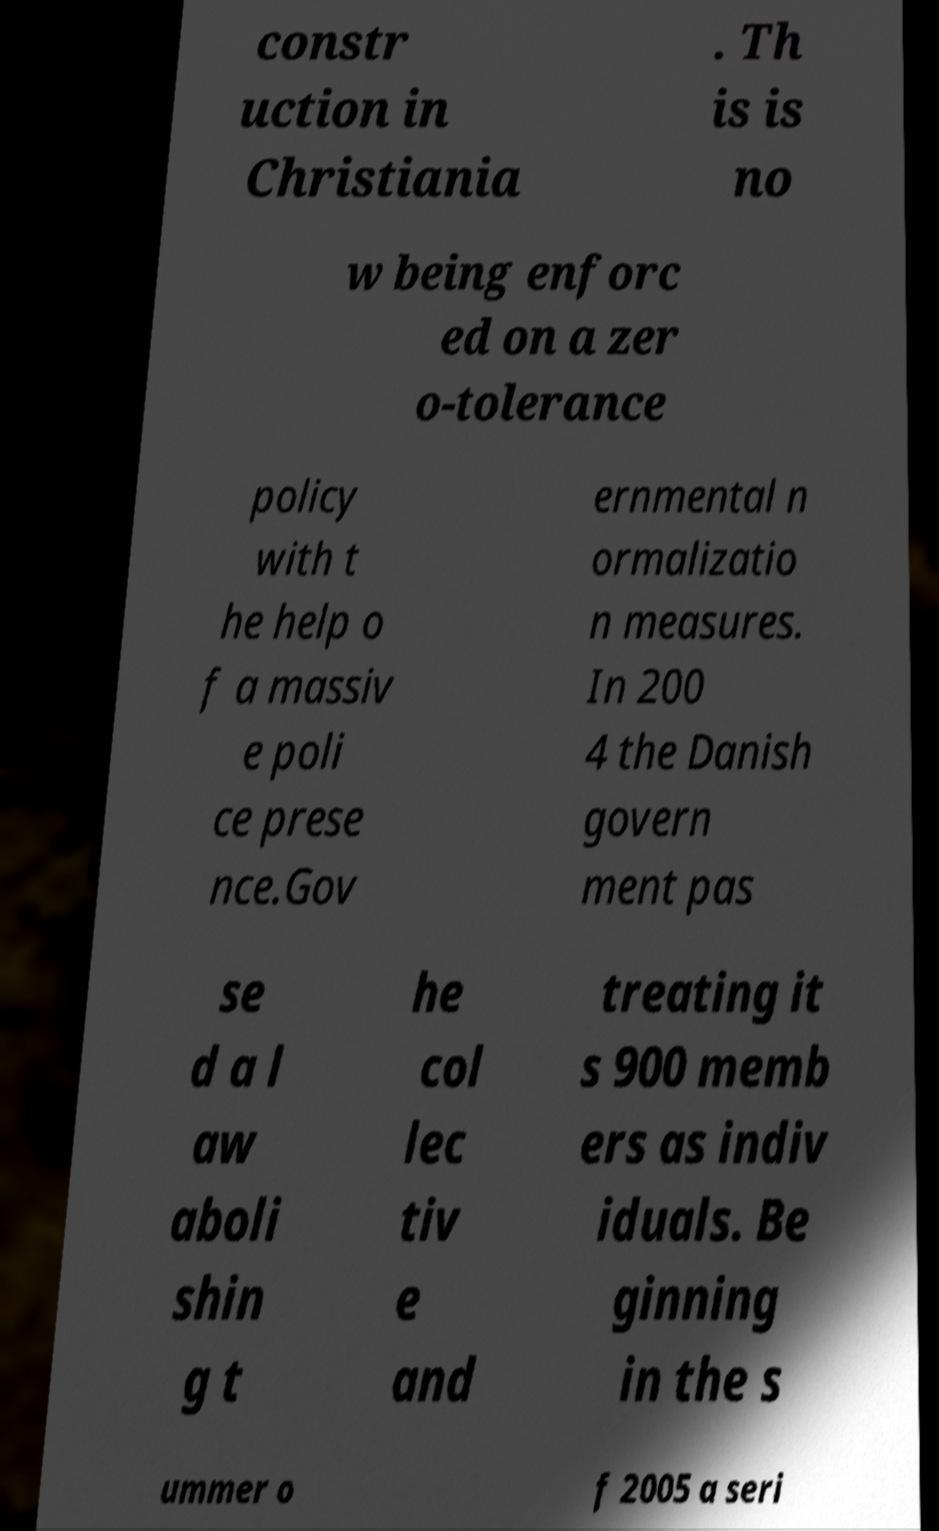Can you read and provide the text displayed in the image?This photo seems to have some interesting text. Can you extract and type it out for me? constr uction in Christiania . Th is is no w being enforc ed on a zer o-tolerance policy with t he help o f a massiv e poli ce prese nce.Gov ernmental n ormalizatio n measures. In 200 4 the Danish govern ment pas se d a l aw aboli shin g t he col lec tiv e and treating it s 900 memb ers as indiv iduals. Be ginning in the s ummer o f 2005 a seri 